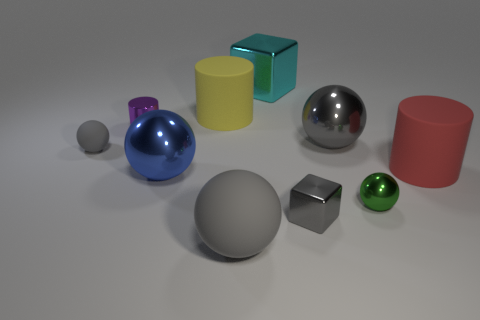How many gray spheres must be subtracted to get 1 gray spheres? 2 Subtract all small green spheres. How many spheres are left? 4 Subtract all green cylinders. How many gray balls are left? 3 Subtract 3 balls. How many balls are left? 2 Subtract all blue balls. How many balls are left? 4 Subtract all blocks. How many objects are left? 8 Subtract 0 red blocks. How many objects are left? 10 Subtract all cyan cylinders. Subtract all blue blocks. How many cylinders are left? 3 Subtract all cyan cubes. Subtract all gray matte things. How many objects are left? 7 Add 1 gray metallic objects. How many gray metallic objects are left? 3 